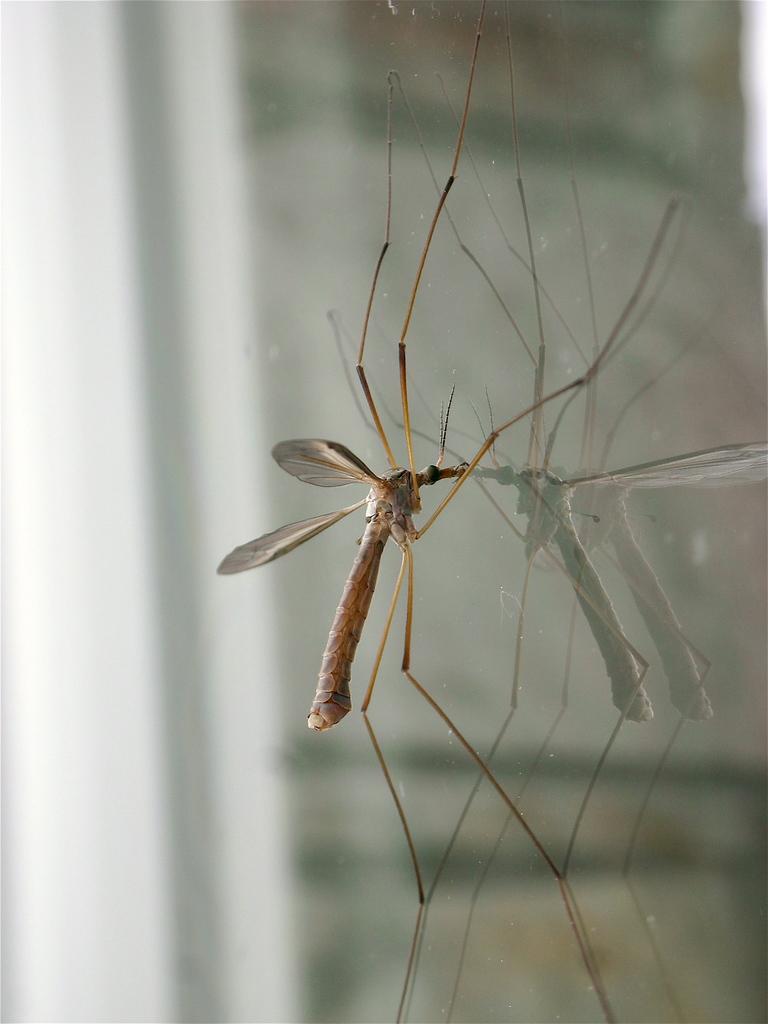Describe this image in one or two sentences. In the center of the picture there is a mosquito on a class object. 